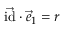Convert formula to latex. <formula><loc_0><loc_0><loc_500><loc_500>\vec { i d } \cdot \vec { e } _ { 1 } = r</formula> 